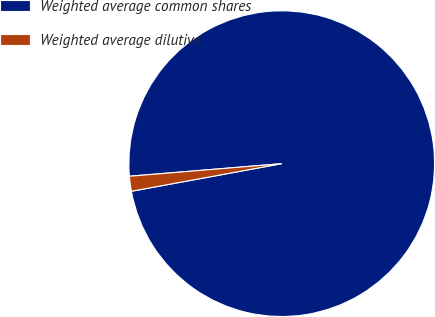<chart> <loc_0><loc_0><loc_500><loc_500><pie_chart><fcel>Weighted average common shares<fcel>Weighted average dilutive<nl><fcel>98.42%<fcel>1.58%<nl></chart> 